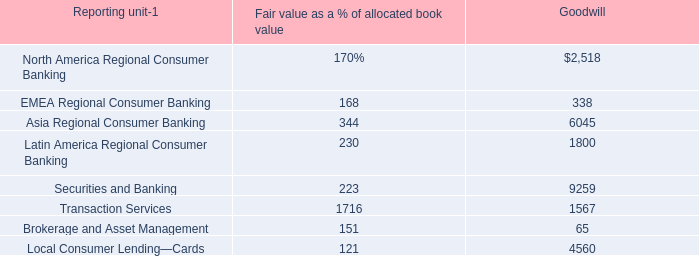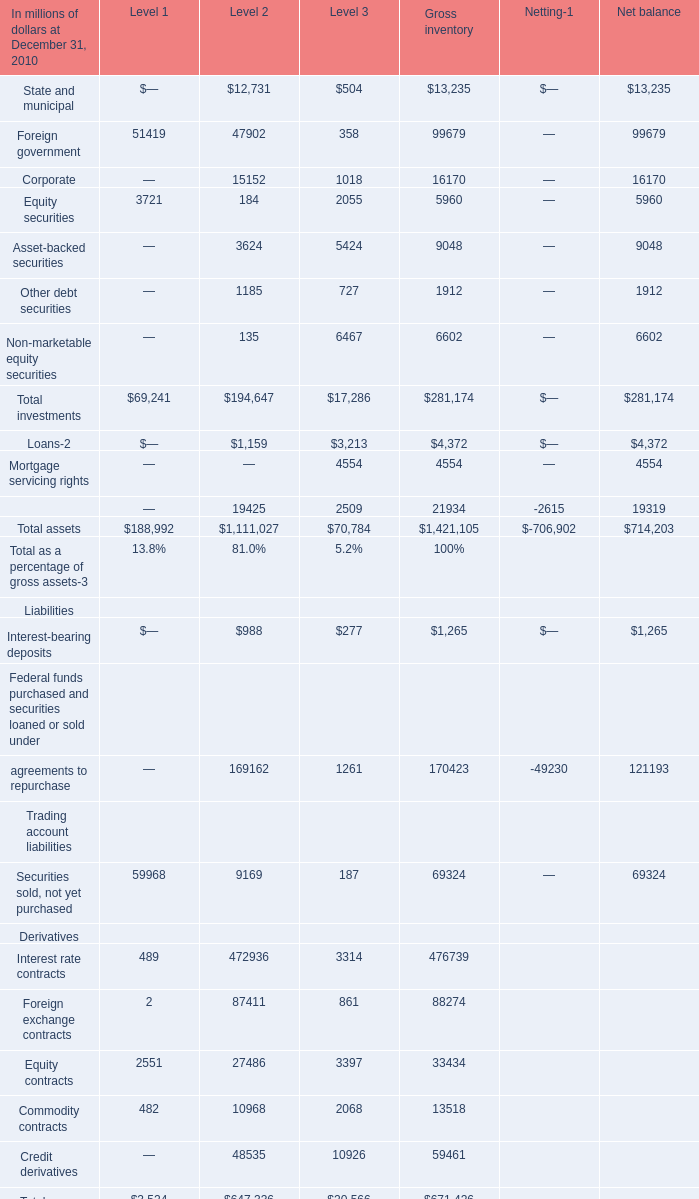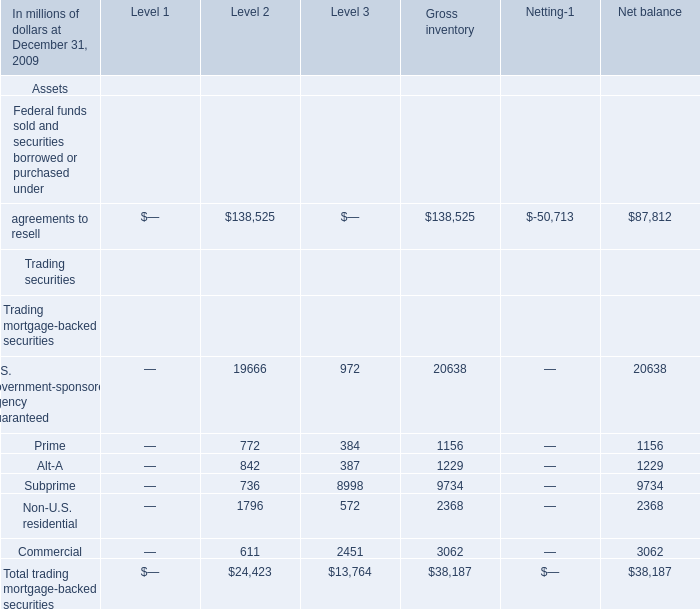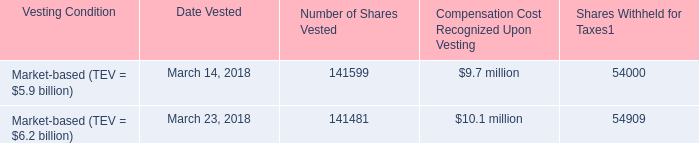What is the sum of Foreign government in for Level 1 and Level 2 and Level 3 ? (in million) 
Computations: ((51419 + 47902) + 358)
Answer: 99679.0. 